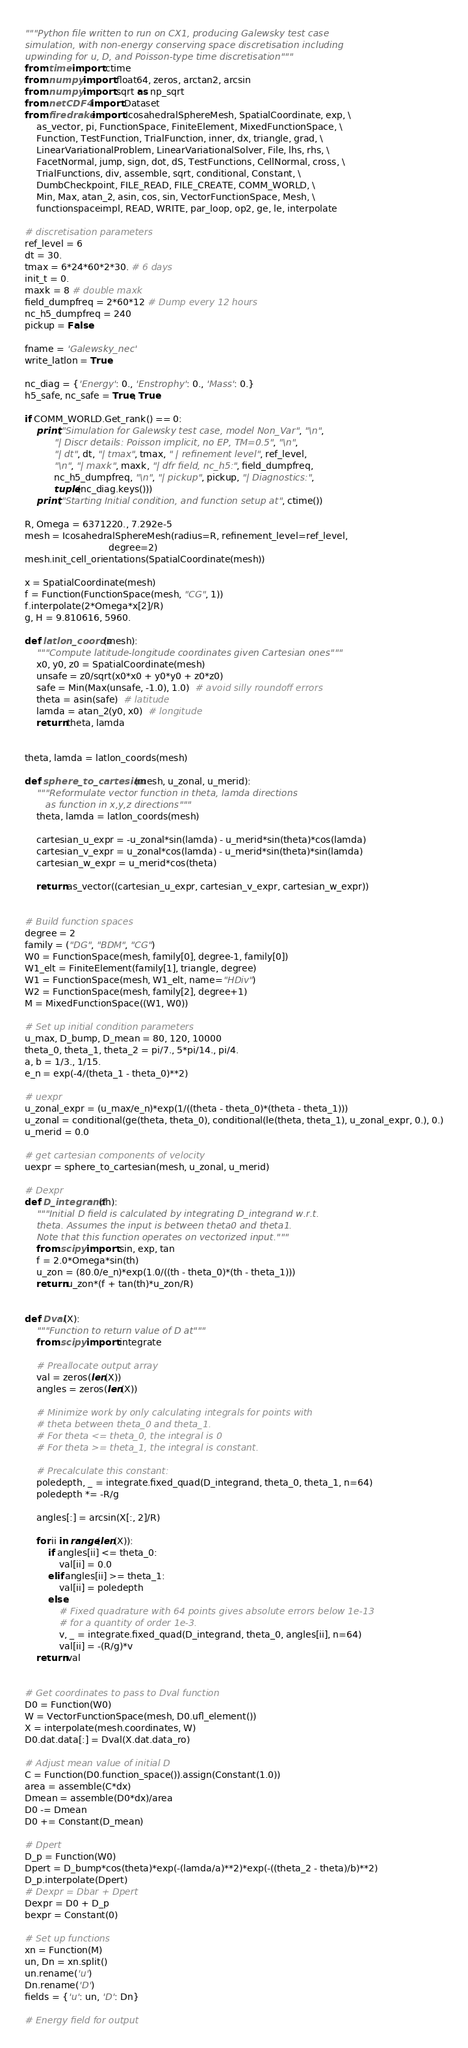<code> <loc_0><loc_0><loc_500><loc_500><_Python_>"""Python file written to run on CX1, producing Galewsky test case
simulation, with non-energy conserving space discretisation including
upwinding for u, D, and Poisson-type time discretisation"""
from time import ctime
from numpy import float64, zeros, arctan2, arcsin
from numpy import sqrt as np_sqrt
from netCDF4 import Dataset
from firedrake import IcosahedralSphereMesh, SpatialCoordinate, exp, \
    as_vector, pi, FunctionSpace, FiniteElement, MixedFunctionSpace, \
    Function, TestFunction, TrialFunction, inner, dx, triangle, grad, \
    LinearVariationalProblem, LinearVariationalSolver, File, lhs, rhs, \
    FacetNormal, jump, sign, dot, dS, TestFunctions, CellNormal, cross, \
    TrialFunctions, div, assemble, sqrt, conditional, Constant, \
    DumbCheckpoint, FILE_READ, FILE_CREATE, COMM_WORLD, \
    Min, Max, atan_2, asin, cos, sin, VectorFunctionSpace, Mesh, \
    functionspaceimpl, READ, WRITE, par_loop, op2, ge, le, interpolate

# discretisation parameters
ref_level = 6
dt = 30.
tmax = 6*24*60*2*30. # 6 days
init_t = 0.
maxk = 8 # double maxk
field_dumpfreq = 2*60*12 # Dump every 12 hours
nc_h5_dumpfreq = 240
pickup = False

fname = 'Galewsky_nec'
write_latlon = True

nc_diag = {'Energy': 0., 'Enstrophy': 0., 'Mass': 0.}
h5_safe, nc_safe = True, True

if COMM_WORLD.Get_rank() == 0:
    print("Simulation for Galewsky test case, model Non_Var", "\n",
          "| Discr details: Poisson implicit, no EP, TM=0.5", "\n",
          "| dt", dt, "| tmax", tmax, " | refinement level", ref_level,
          "\n", "| maxk", maxk, "| dfr field, nc_h5:", field_dumpfreq,
          nc_h5_dumpfreq, "\n", "| pickup", pickup, "| Diagnostics:",
          tuple(nc_diag.keys()))
    print("Starting Initial condition, and function setup at", ctime())

R, Omega = 6371220., 7.292e-5
mesh = IcosahedralSphereMesh(radius=R, refinement_level=ref_level,
                             degree=2)
mesh.init_cell_orientations(SpatialCoordinate(mesh))

x = SpatialCoordinate(mesh)
f = Function(FunctionSpace(mesh, "CG", 1))
f.interpolate(2*Omega*x[2]/R)
g, H = 9.810616, 5960.

def latlon_coords(mesh):
    """Compute latitude-longitude coordinates given Cartesian ones"""
    x0, y0, z0 = SpatialCoordinate(mesh)
    unsafe = z0/sqrt(x0*x0 + y0*y0 + z0*z0)
    safe = Min(Max(unsafe, -1.0), 1.0)  # avoid silly roundoff errors
    theta = asin(safe)  # latitude
    lamda = atan_2(y0, x0)  # longitude
    return theta, lamda


theta, lamda = latlon_coords(mesh)

def sphere_to_cartesian(mesh, u_zonal, u_merid):
    """Reformulate vector function in theta, lamda directions
       as function in x,y,z directions"""
    theta, lamda = latlon_coords(mesh)

    cartesian_u_expr = -u_zonal*sin(lamda) - u_merid*sin(theta)*cos(lamda)
    cartesian_v_expr = u_zonal*cos(lamda) - u_merid*sin(theta)*sin(lamda)
    cartesian_w_expr = u_merid*cos(theta)

    return as_vector((cartesian_u_expr, cartesian_v_expr, cartesian_w_expr))


# Build function spaces
degree = 2
family = ("DG", "BDM", "CG")
W0 = FunctionSpace(mesh, family[0], degree-1, family[0])
W1_elt = FiniteElement(family[1], triangle, degree)
W1 = FunctionSpace(mesh, W1_elt, name="HDiv")
W2 = FunctionSpace(mesh, family[2], degree+1)
M = MixedFunctionSpace((W1, W0))

# Set up initial condition parameters
u_max, D_bump, D_mean = 80, 120, 10000
theta_0, theta_1, theta_2 = pi/7., 5*pi/14., pi/4.
a, b = 1/3., 1/15.
e_n = exp(-4/(theta_1 - theta_0)**2)

# uexpr
u_zonal_expr = (u_max/e_n)*exp(1/((theta - theta_0)*(theta - theta_1)))
u_zonal = conditional(ge(theta, theta_0), conditional(le(theta, theta_1), u_zonal_expr, 0.), 0.)
u_merid = 0.0

# get cartesian components of velocity
uexpr = sphere_to_cartesian(mesh, u_zonal, u_merid)

# Dexpr
def D_integrand(th):
    """Initial D field is calculated by integrating D_integrand w.r.t.
    theta. Assumes the input is between theta0 and theta1.
    Note that this function operates on vectorized input."""
    from scipy import sin, exp, tan
    f = 2.0*Omega*sin(th)
    u_zon = (80.0/e_n)*exp(1.0/((th - theta_0)*(th - theta_1)))
    return u_zon*(f + tan(th)*u_zon/R)


def Dval(X):
    """Function to return value of D at"""
    from scipy import integrate

    # Preallocate output array
    val = zeros(len(X))
    angles = zeros(len(X))

    # Minimize work by only calculating integrals for points with
    # theta between theta_0 and theta_1.
    # For theta <= theta_0, the integral is 0
    # For theta >= theta_1, the integral is constant.

    # Precalculate this constant:
    poledepth, _ = integrate.fixed_quad(D_integrand, theta_0, theta_1, n=64)
    poledepth *= -R/g

    angles[:] = arcsin(X[:, 2]/R)

    for ii in range(len(X)):
        if angles[ii] <= theta_0:
            val[ii] = 0.0
        elif angles[ii] >= theta_1:
            val[ii] = poledepth
        else:
            # Fixed quadrature with 64 points gives absolute errors below 1e-13
            # for a quantity of order 1e-3.
            v, _ = integrate.fixed_quad(D_integrand, theta_0, angles[ii], n=64)
            val[ii] = -(R/g)*v
    return val


# Get coordinates to pass to Dval function
D0 = Function(W0)
W = VectorFunctionSpace(mesh, D0.ufl_element())
X = interpolate(mesh.coordinates, W)
D0.dat.data[:] = Dval(X.dat.data_ro)

# Adjust mean value of initial D
C = Function(D0.function_space()).assign(Constant(1.0))
area = assemble(C*dx)
Dmean = assemble(D0*dx)/area
D0 -= Dmean
D0 += Constant(D_mean)

# Dpert
D_p = Function(W0)
Dpert = D_bump*cos(theta)*exp(-(lamda/a)**2)*exp(-((theta_2 - theta)/b)**2)
D_p.interpolate(Dpert)
# Dexpr = Dbar + Dpert
Dexpr = D0 + D_p
bexpr = Constant(0)

# Set up functions
xn = Function(M)
un, Dn = xn.split()
un.rename('u')
Dn.rename('D')
fields = {'u': un, 'D': Dn}

# Energy field for output</code> 